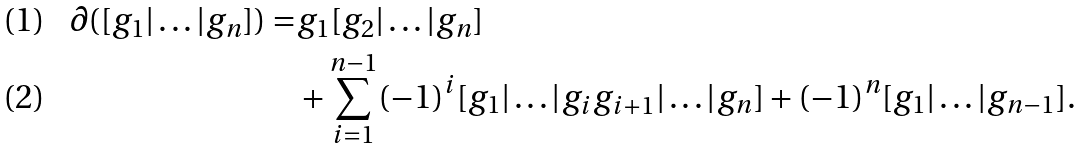<formula> <loc_0><loc_0><loc_500><loc_500>\partial ( [ g _ { 1 } | \dots | g _ { n } ] ) = & g _ { 1 } [ g _ { 2 } | \dots | g _ { n } ] \\ & + \sum _ { i = 1 } ^ { n - 1 } ( - 1 ) ^ { i } [ g _ { 1 } | \dots | g _ { i } g _ { i + 1 } | \dots | g _ { n } ] + ( - 1 ) ^ { n } [ g _ { 1 } | \dots | g _ { n - 1 } ] .</formula> 